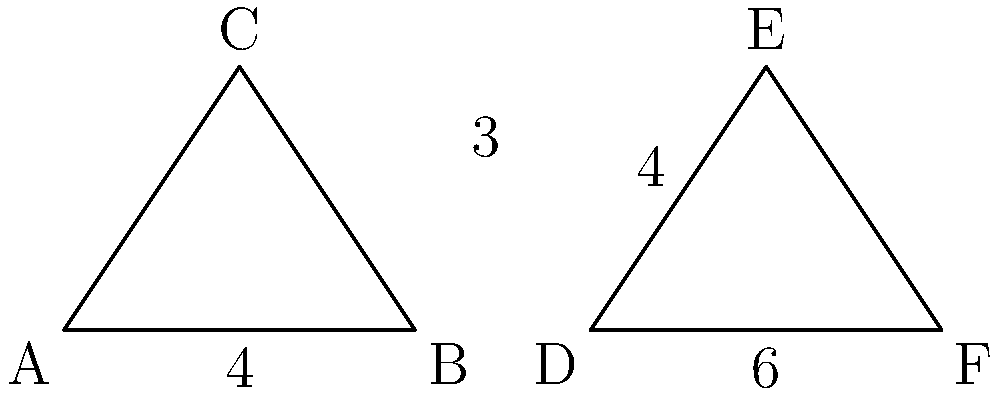In a special teams play, two triangular formations are set up as shown in the diagram. Triangle ABC represents your team's formation, while triangle DEF represents the opponent's formation. Given that $\overline{AB} = 4$ yards, $\overline{BC} = 3$ yards, $\overline{DE} = 4$ yards, and $\overline{EF} = 6$ yards, determine if these triangles are congruent. If they are congruent, state the congruence criterion used. To determine if the triangles are congruent, we need to compare their sides and angles. Let's approach this step-by-step:

1) We are given that $\overline{AB} = 4$ yards and $\overline{DE} = 4$ yards, so one pair of sides is equal.

2) We are also given that $\overline{BC} = 3$ yards and $\overline{EF} = 6$ yards. These sides are not equal.

3) The third sides ($\overline{AC}$ and $\overline{DF}$) are not given, but we can see they are different lengths.

4) Since we've found that two corresponding sides are not equal, we can conclude that the triangles are not congruent.

5) For triangles to be congruent, they must satisfy one of the congruence criteria:
   - SSS (Side-Side-Side): All three pairs of corresponding sides are equal
   - SAS (Side-Angle-Side): Two pairs of corresponding sides and the included angle are equal
   - ASA (Angle-Side-Angle): Two pairs of corresponding angles and the included side are equal
   - AAS (Angle-Angle-Side): Two pairs of corresponding angles and a non-included side are equal

6) In this case, we only have one pair of equal sides, which is not sufficient for any of the congruence criteria.

Therefore, the triangles ABC and DEF are not congruent.
Answer: Not congruent 